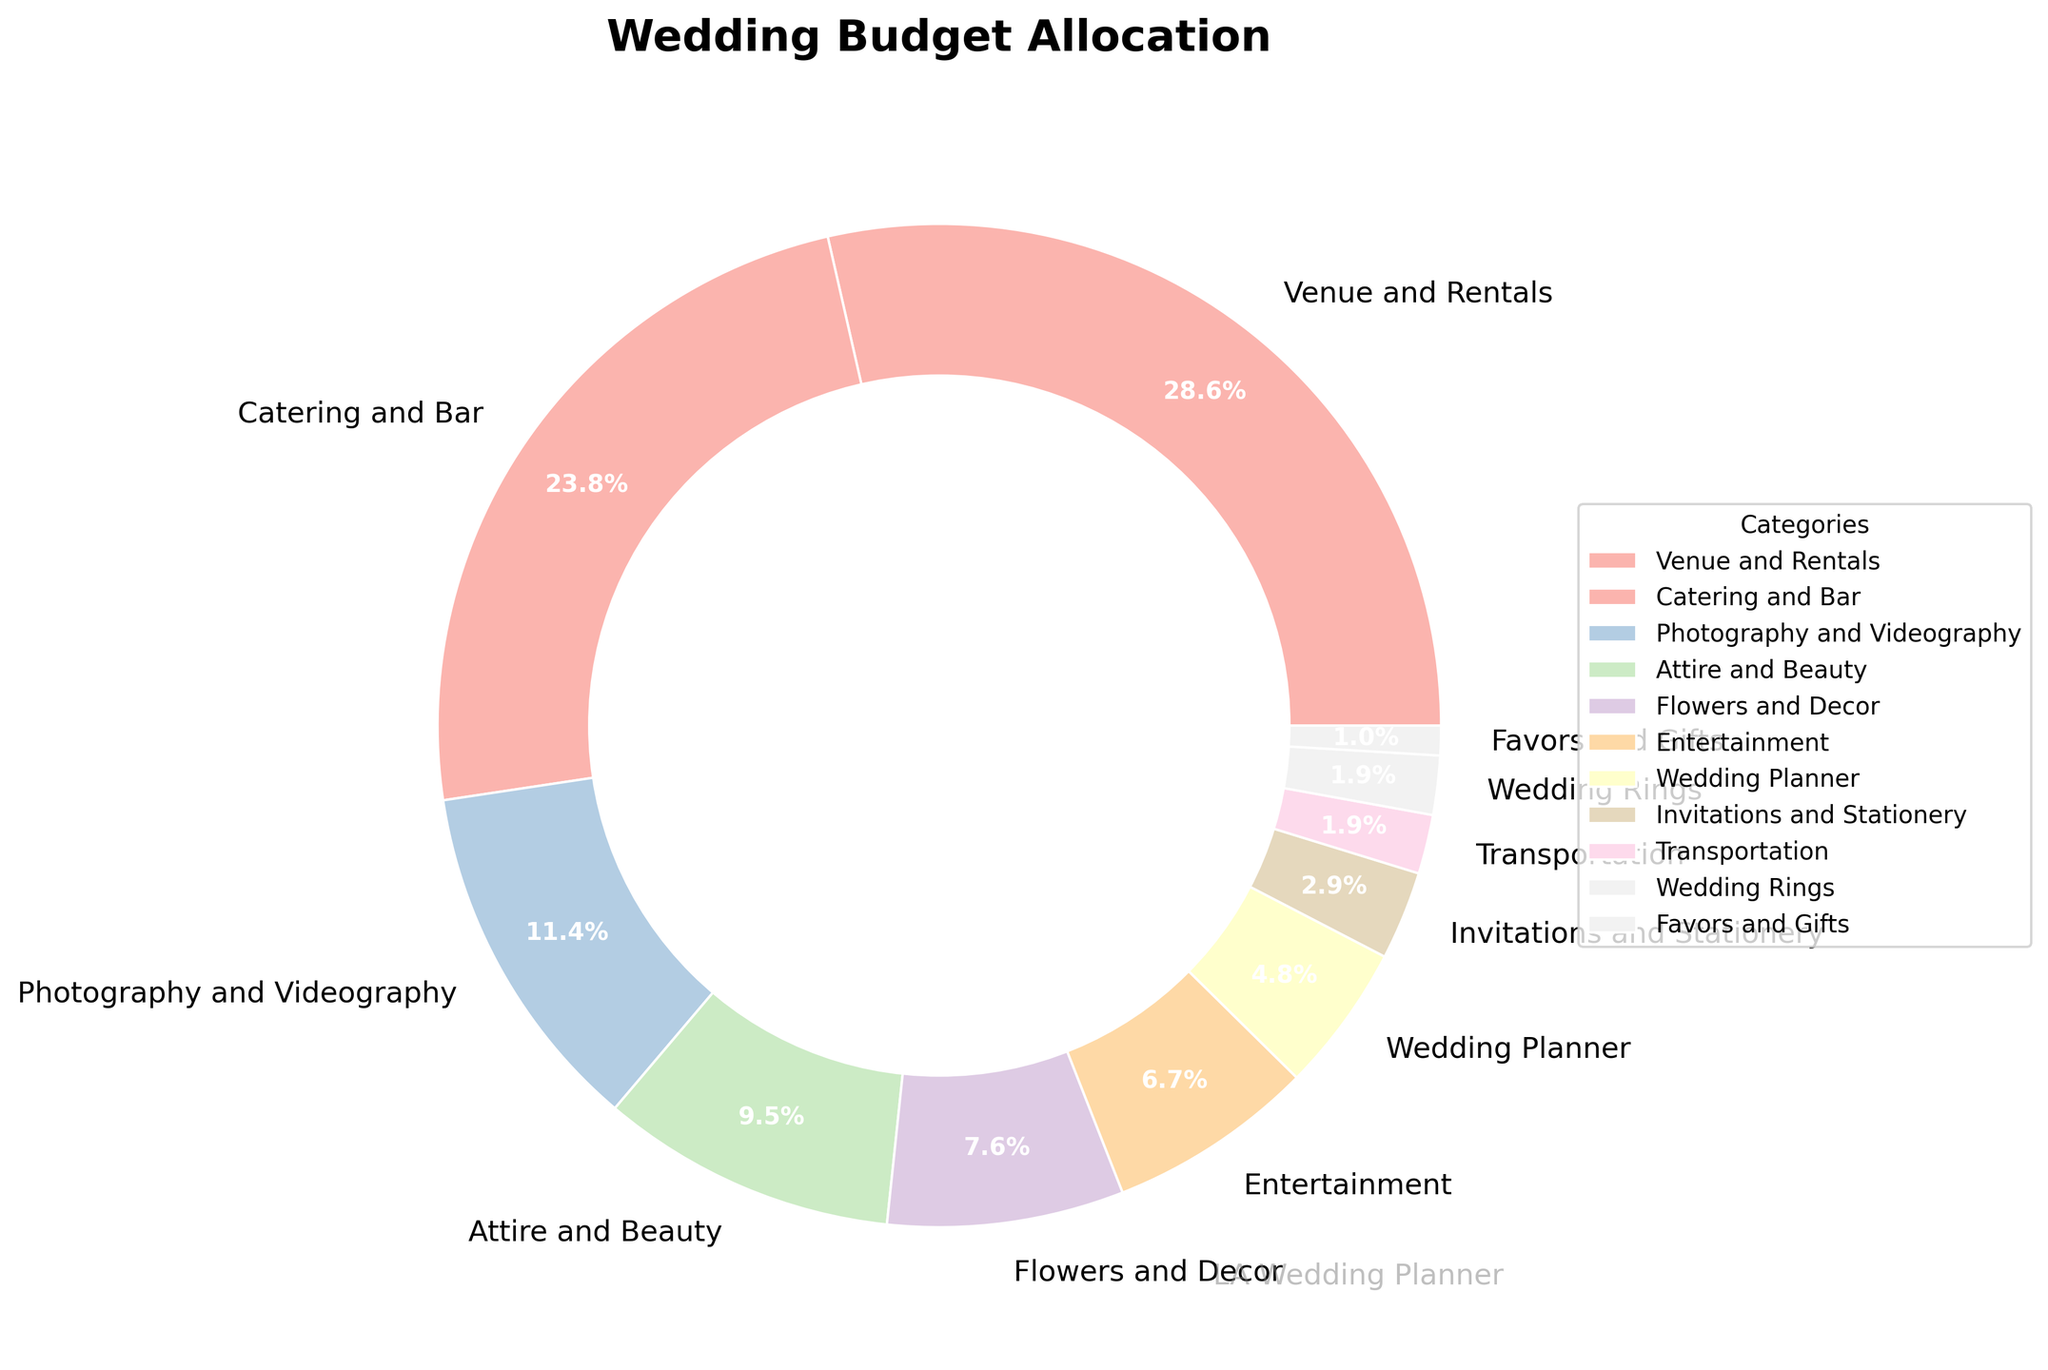What is the largest allocation category in the wedding budget? The largest allocation category in the wedding budget can be identified by looking at the category with the highest percentage in the pie chart.
Answer: Venue and Rentals Which category has more budget allocation: Flowers and Decor or Transportation? Compare the percentages for "Flowers and Decor" and "Transportation". "Flowers and Decor" has 8% whereas "Transportation" has 2%.
Answer: Flowers and Decor What is the total percentage allocation for Photography and Videography, and Attire and Beauty combined? Add the percentages of "Photography and Videography" (12%) and "Attire and Beauty" (10%). The total is 12% + 10% = 22%.
Answer: 22% Which category has the smallest budget allocation? The smallest segment in the pie chart represents the category with the smallest budget allocation.
Answer: Favors and Gifts If the total wedding budget is $50,000, how much money is allocated to Catering and Bar? Calculate 25% of $50,000 for the Catering and Bar category. That is 0.25 * 50,000 = 12,500.
Answer: $12,500 Does Wedding Planner have a higher allocation than Invitations and Stationery? Compare the percentages of "Wedding Planner" (5%) and "Invitations and Stationery" (3%). "Wedding Planner" has a higher allocation.
Answer: Yes What is the combined percentage allocation of Venue and Rentals, and Catering and Bar? Add the percentages of "Venue and Rentals" (30%) and "Catering and Bar" (25%). The total is 30% + 25% = 55%.
Answer: 55% Which category is allocated more budget: Entertainment or Transportation and Wedding Rings combined? First, find the combined percentage of "Transportation" (2%) and "Wedding Rings" (2%), which is 2% + 2% = 4%. Then compare it with "Entertainment" at 7%.
Answer: Entertainment Given that the total budget is $100,000, how much is allocated to the Entertainment category? Calculate 7% of $100,000 for the Entertainment category. That is 0.07 * $100,000 = $7,000.
Answer: $7,000 